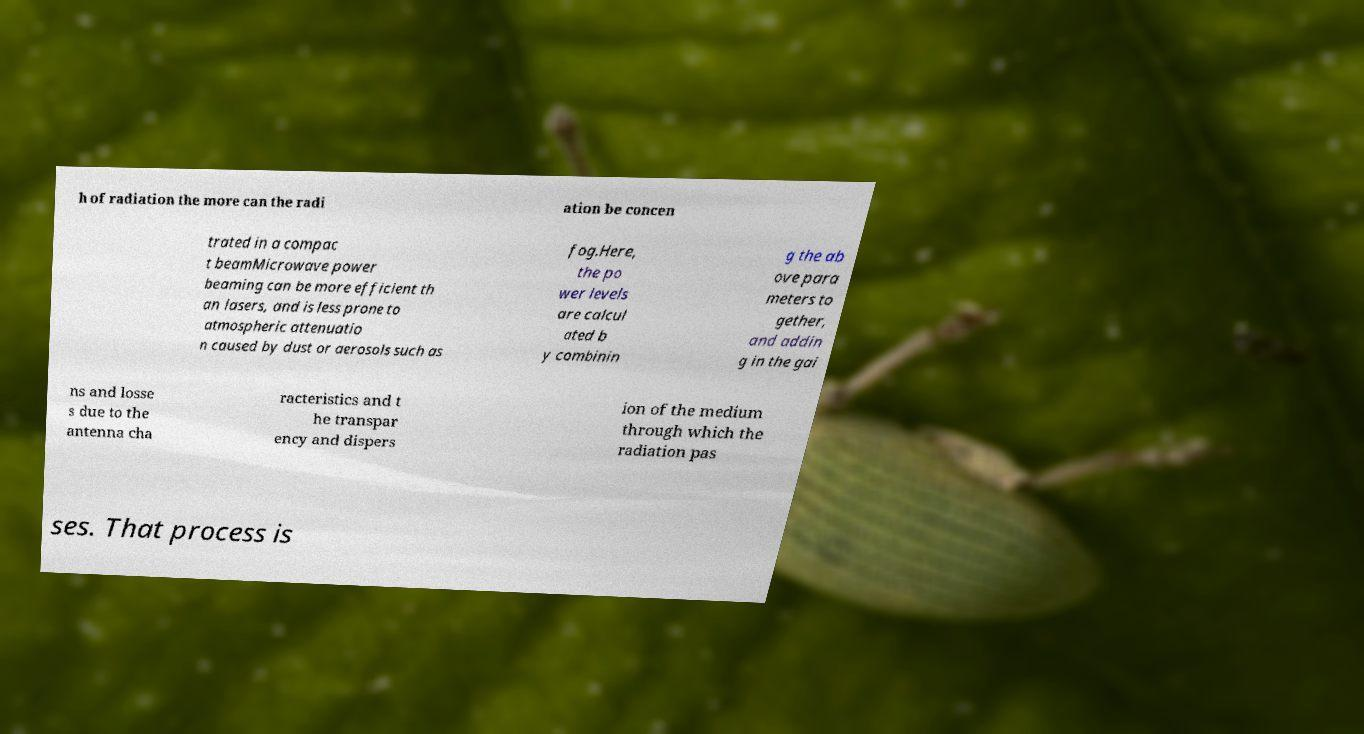For documentation purposes, I need the text within this image transcribed. Could you provide that? h of radiation the more can the radi ation be concen trated in a compac t beamMicrowave power beaming can be more efficient th an lasers, and is less prone to atmospheric attenuatio n caused by dust or aerosols such as fog.Here, the po wer levels are calcul ated b y combinin g the ab ove para meters to gether, and addin g in the gai ns and losse s due to the antenna cha racteristics and t he transpar ency and dispers ion of the medium through which the radiation pas ses. That process is 